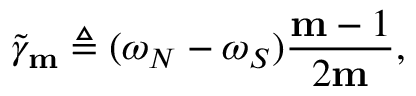Convert formula to latex. <formula><loc_0><loc_0><loc_500><loc_500>\widetilde { \gamma } _ { m } \triangle q ( \omega _ { N } - \omega _ { S } ) \frac { m - 1 } { 2 m } ,</formula> 